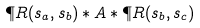<formula> <loc_0><loc_0><loc_500><loc_500>\P R ( s _ { a } , s _ { b } ) \ast A \ast \P R ( s _ { b } , s _ { c } ) \,</formula> 